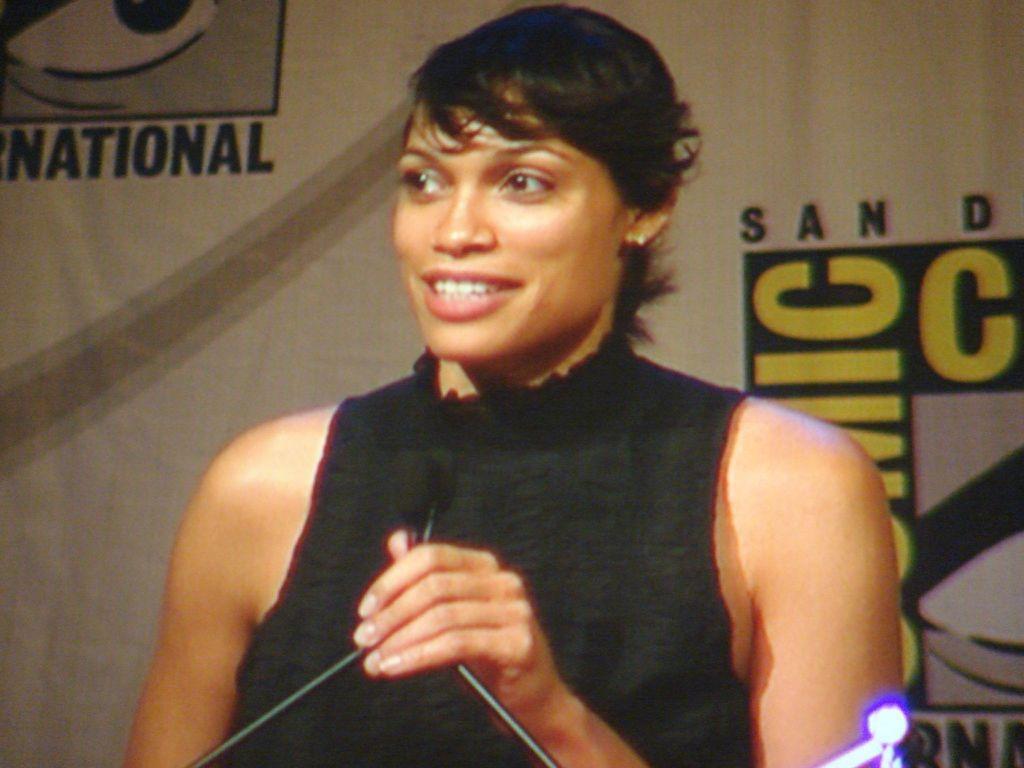In one or two sentences, can you explain what this image depicts? In this picture we can see a woman is smiling, there is a microphone in front of her, in the background there is some text. 